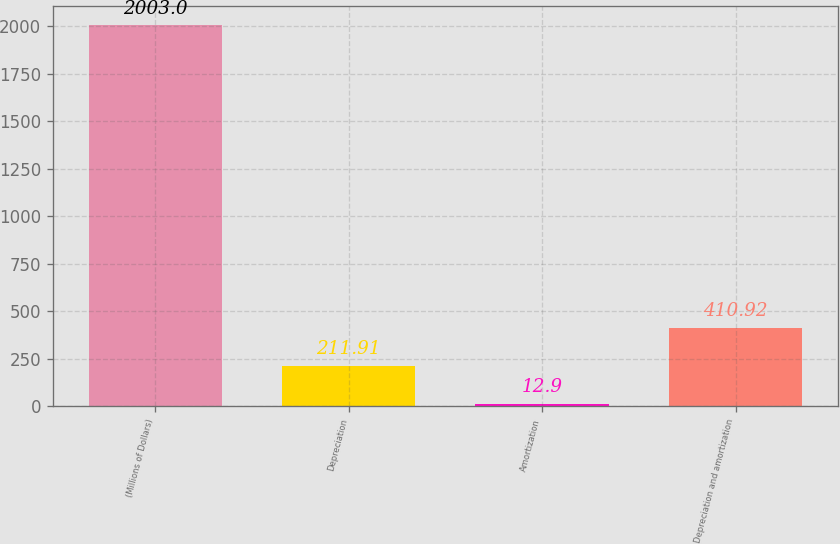<chart> <loc_0><loc_0><loc_500><loc_500><bar_chart><fcel>(Millions of Dollars)<fcel>Depreciation<fcel>Amortization<fcel>Depreciation and amortization<nl><fcel>2003<fcel>211.91<fcel>12.9<fcel>410.92<nl></chart> 